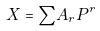<formula> <loc_0><loc_0><loc_500><loc_500>X = { \sum } A _ { r } P ^ { r }</formula> 